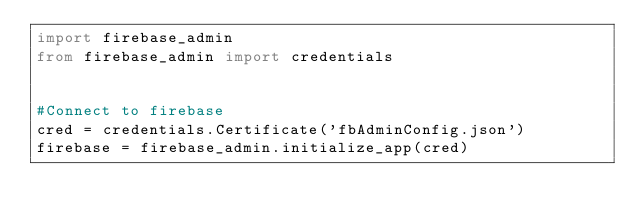<code> <loc_0><loc_0><loc_500><loc_500><_Python_>import firebase_admin
from firebase_admin import credentials


#Connect to firebase
cred = credentials.Certificate('fbAdminConfig.json')
firebase = firebase_admin.initialize_app(cred)
</code> 